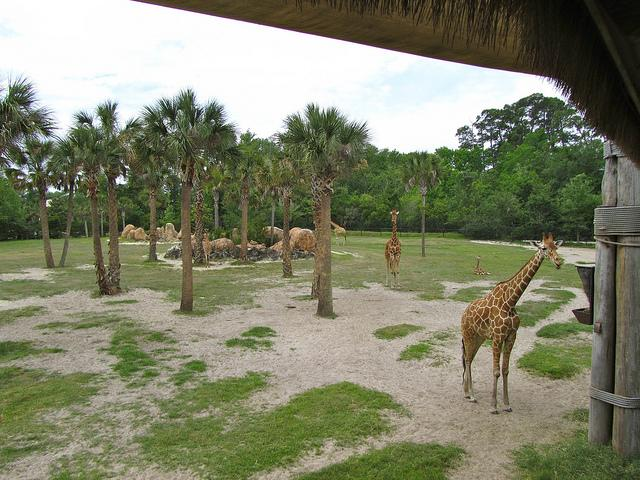What kind of structure is the animal all the way to the right looking at? wooden 